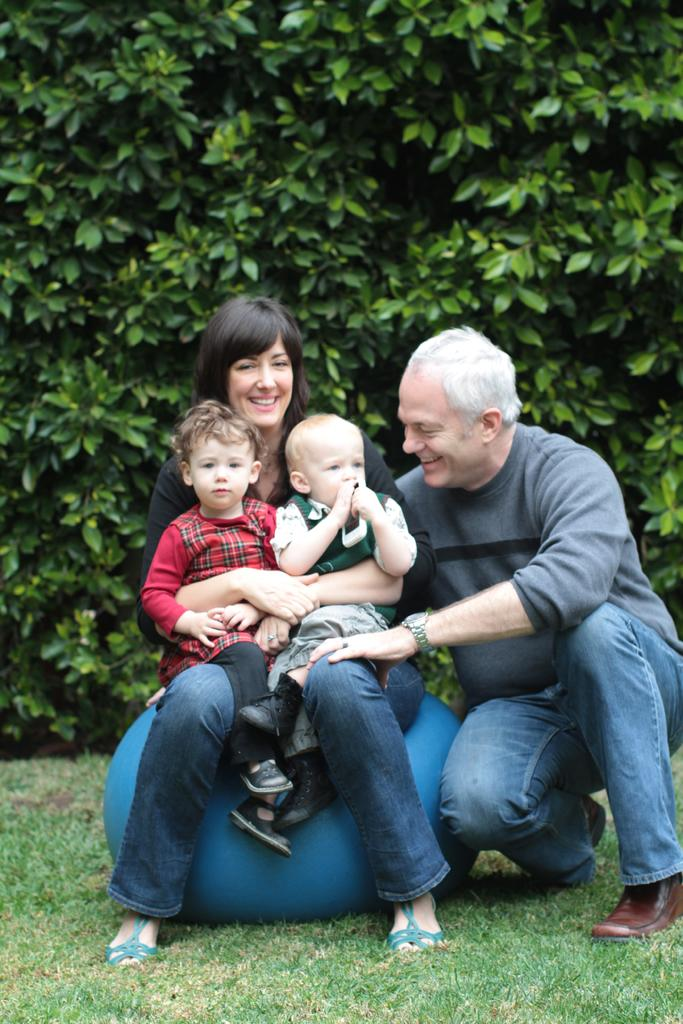What is the person in the image doing with the exercise ball? The person is sitting on an exercise ball in the image. Who else is present in the image? There is another person sitting on the grass in the image. What is the person holding while sitting on the exercise ball? The person is holding a child. What can be seen in the background of the image? There are trees visible in the background of the image. What type of fiction is the farmer reading to the child in the image? There is no farmer or fiction present in the image; it features a person sitting on an exercise ball holding a child. What kind of house is visible in the background of the image? There is no house visible in the background of the image; it features trees. 